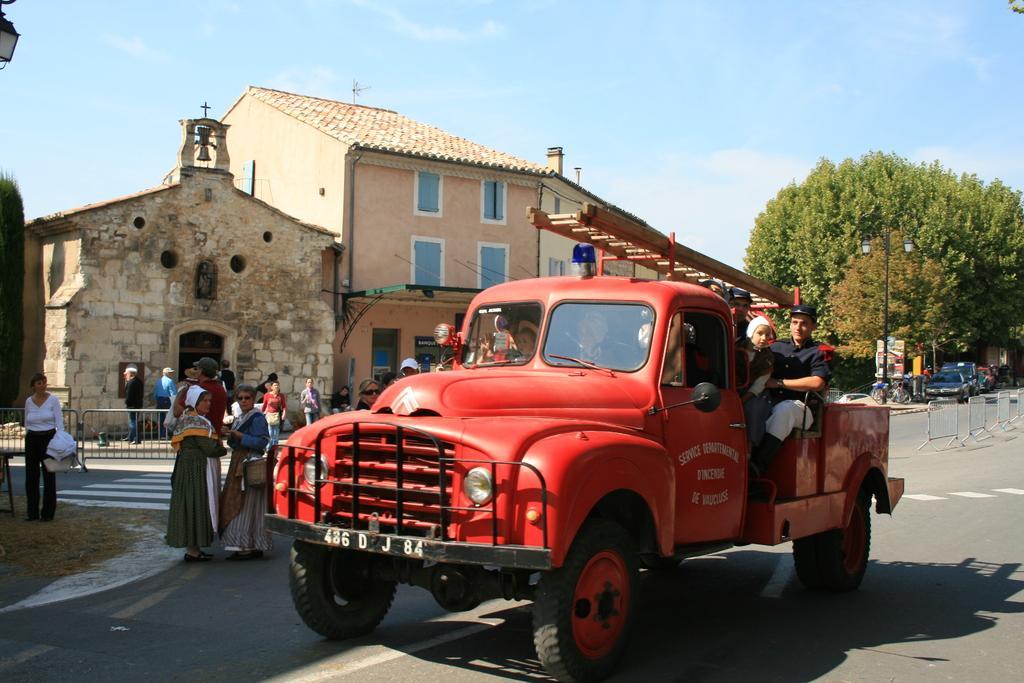Could you give a brief overview of what you see in this image? In front of the image there are people sitting inside the car. Behind the car there are a few other people standing on the road. There is a metal fence. There are cars, cycles. There are light poles, boards. In the background of the image there are buildings, trees and sky. 